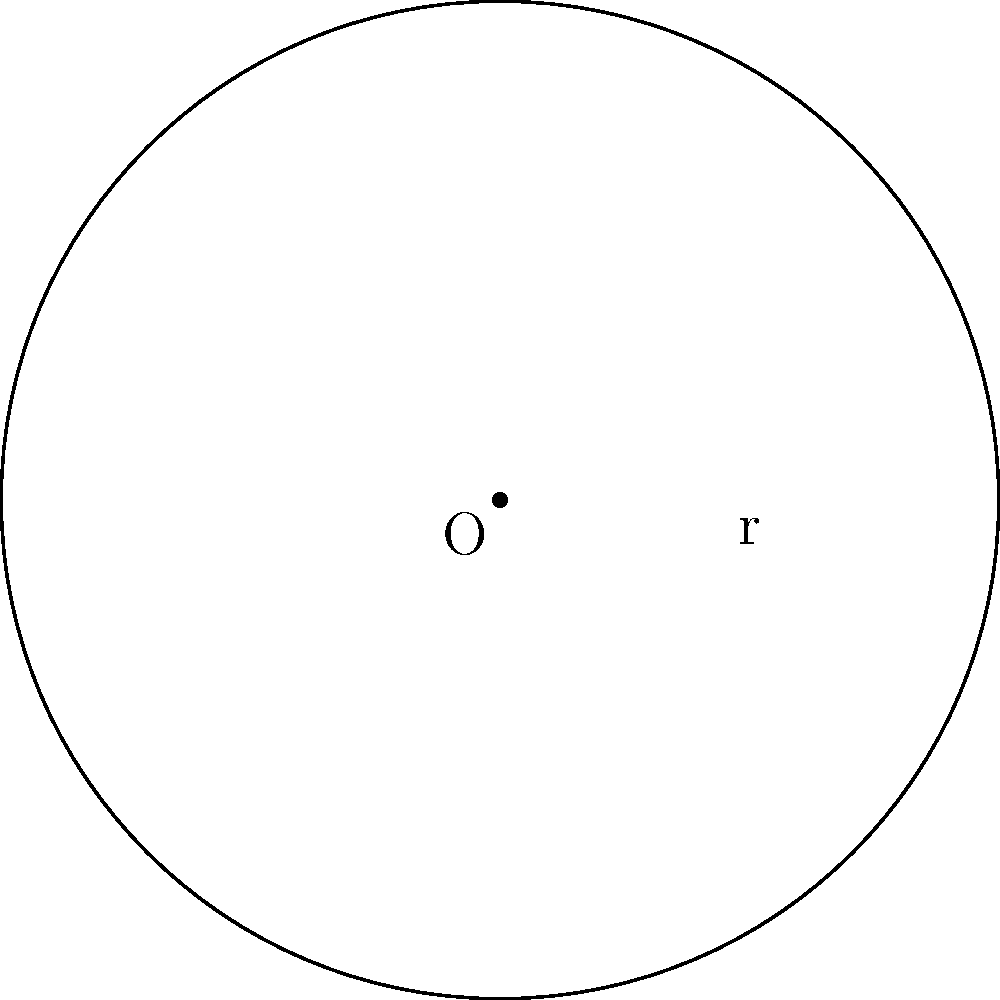A circular diffuser pad has a radius of 3 cm. If the scent intensity is directly proportional to the area of the pad, and doubling the radius increases the scent intensity by 300%, what is the relationship between the radius and the area of the pad? Let's approach this step-by-step:

1) The area of a circle is given by the formula $A = \pi r^2$, where $r$ is the radius.

2) Initially, the area is $A_1 = \pi (3)^2 = 9\pi$ cm².

3) When we double the radius, the new radius is 6 cm, and the new area is:
   $A_2 = \pi (6)^2 = 36\pi$ cm²

4) The question states that this increase in area corresponds to a 300% increase in scent intensity. Let's express this mathematically:
   $\frac{A_2 - A_1}{A_1} \times 100\% = 300\%$

5) Substituting the values:
   $\frac{36\pi - 9\pi}{9\pi} \times 100\% = 300\%$
   $\frac{27\pi}{9\pi} \times 100\% = 300\%$
   $3 \times 100\% = 300\%$

6) This shows that when the radius is doubled (increased by a factor of 2), the area (and thus the scent intensity) is quadrupled (increased by a factor of 4).

7) In general, if we increase the radius by a factor of $k$, the new area will be:
   $A_{\text{new}} = \pi (kr)^2 = k^2 \pi r^2 = k^2 A_{\text{original}}$

Therefore, the area (and scent intensity) is proportional to the square of the radius.
Answer: The area (and scent intensity) is proportional to $r^2$. 